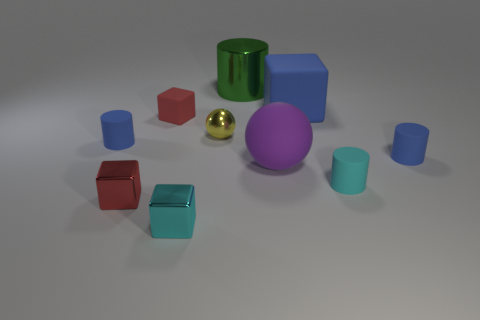Subtract 1 cylinders. How many cylinders are left? 3 Subtract all green cylinders. How many cylinders are left? 3 Subtract all gray cylinders. Subtract all gray cubes. How many cylinders are left? 4 Add 5 tiny blue rubber cylinders. How many tiny blue rubber cylinders exist? 7 Subtract 2 red cubes. How many objects are left? 8 Subtract all blocks. How many objects are left? 6 Subtract all large shiny cubes. Subtract all small things. How many objects are left? 3 Add 1 tiny cyan objects. How many tiny cyan objects are left? 3 